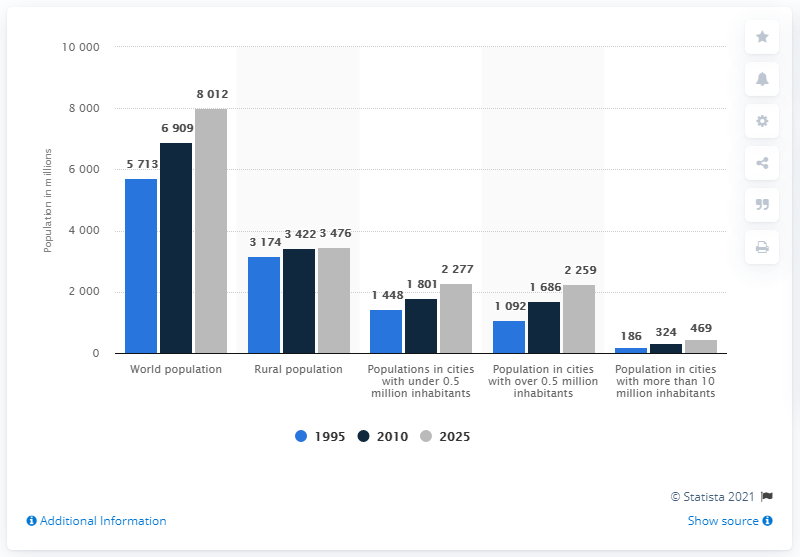List a handful of essential elements in this visual. According to the data, approximately 3422 out of the 6.9 billion people living in the country reside in urban and rural areas. It is estimated that approximately 6,909 people reside in the country. 